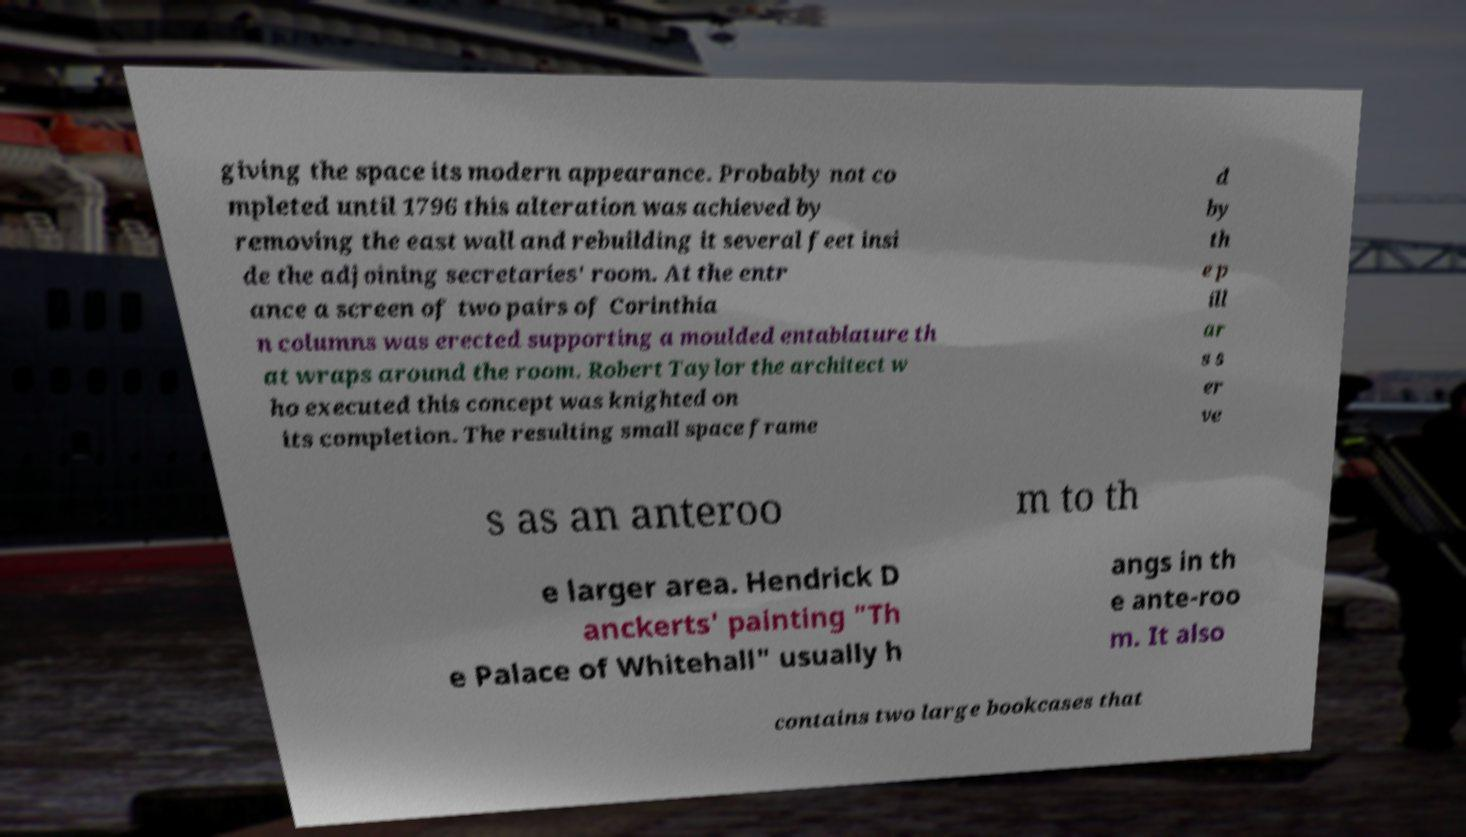For documentation purposes, I need the text within this image transcribed. Could you provide that? giving the space its modern appearance. Probably not co mpleted until 1796 this alteration was achieved by removing the east wall and rebuilding it several feet insi de the adjoining secretaries' room. At the entr ance a screen of two pairs of Corinthia n columns was erected supporting a moulded entablature th at wraps around the room. Robert Taylor the architect w ho executed this concept was knighted on its completion. The resulting small space frame d by th e p ill ar s s er ve s as an anteroo m to th e larger area. Hendrick D anckerts' painting "Th e Palace of Whitehall" usually h angs in th e ante-roo m. It also contains two large bookcases that 